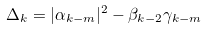<formula> <loc_0><loc_0><loc_500><loc_500>\Delta _ { k } = | \alpha _ { k - m } | ^ { 2 } - \beta _ { k - 2 } \gamma _ { k - m }</formula> 